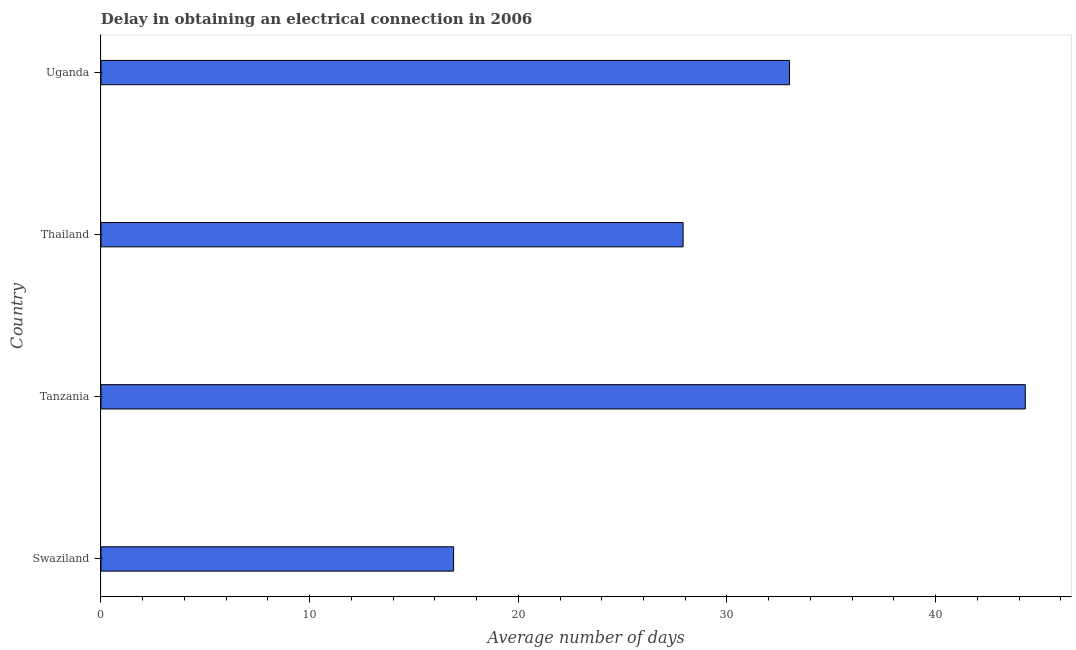Does the graph contain any zero values?
Your answer should be compact. No. Does the graph contain grids?
Ensure brevity in your answer.  No. What is the title of the graph?
Give a very brief answer. Delay in obtaining an electrical connection in 2006. What is the label or title of the X-axis?
Your answer should be compact. Average number of days. What is the dalay in electrical connection in Uganda?
Provide a short and direct response. 33. Across all countries, what is the maximum dalay in electrical connection?
Keep it short and to the point. 44.3. In which country was the dalay in electrical connection maximum?
Your answer should be compact. Tanzania. In which country was the dalay in electrical connection minimum?
Make the answer very short. Swaziland. What is the sum of the dalay in electrical connection?
Offer a very short reply. 122.1. What is the difference between the dalay in electrical connection in Swaziland and Thailand?
Give a very brief answer. -11. What is the average dalay in electrical connection per country?
Your response must be concise. 30.52. What is the median dalay in electrical connection?
Ensure brevity in your answer.  30.45. In how many countries, is the dalay in electrical connection greater than 4 days?
Your answer should be compact. 4. What is the ratio of the dalay in electrical connection in Swaziland to that in Thailand?
Provide a short and direct response. 0.61. Is the dalay in electrical connection in Thailand less than that in Uganda?
Ensure brevity in your answer.  Yes. Is the sum of the dalay in electrical connection in Swaziland and Thailand greater than the maximum dalay in electrical connection across all countries?
Provide a short and direct response. Yes. What is the difference between the highest and the lowest dalay in electrical connection?
Offer a very short reply. 27.4. In how many countries, is the dalay in electrical connection greater than the average dalay in electrical connection taken over all countries?
Give a very brief answer. 2. How many bars are there?
Your response must be concise. 4. What is the difference between two consecutive major ticks on the X-axis?
Your response must be concise. 10. Are the values on the major ticks of X-axis written in scientific E-notation?
Offer a terse response. No. What is the Average number of days in Tanzania?
Ensure brevity in your answer.  44.3. What is the Average number of days of Thailand?
Keep it short and to the point. 27.9. What is the difference between the Average number of days in Swaziland and Tanzania?
Your answer should be compact. -27.4. What is the difference between the Average number of days in Swaziland and Uganda?
Offer a terse response. -16.1. What is the difference between the Average number of days in Tanzania and Thailand?
Make the answer very short. 16.4. What is the difference between the Average number of days in Tanzania and Uganda?
Make the answer very short. 11.3. What is the difference between the Average number of days in Thailand and Uganda?
Ensure brevity in your answer.  -5.1. What is the ratio of the Average number of days in Swaziland to that in Tanzania?
Provide a short and direct response. 0.38. What is the ratio of the Average number of days in Swaziland to that in Thailand?
Your answer should be very brief. 0.61. What is the ratio of the Average number of days in Swaziland to that in Uganda?
Your answer should be very brief. 0.51. What is the ratio of the Average number of days in Tanzania to that in Thailand?
Offer a very short reply. 1.59. What is the ratio of the Average number of days in Tanzania to that in Uganda?
Provide a short and direct response. 1.34. What is the ratio of the Average number of days in Thailand to that in Uganda?
Offer a terse response. 0.84. 